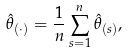Convert formula to latex. <formula><loc_0><loc_0><loc_500><loc_500>\hat { \theta } _ { ( \cdot ) } = \frac { 1 } { n } \sum _ { s = 1 } ^ { n } \hat { \theta } _ { ( s ) } ,</formula> 